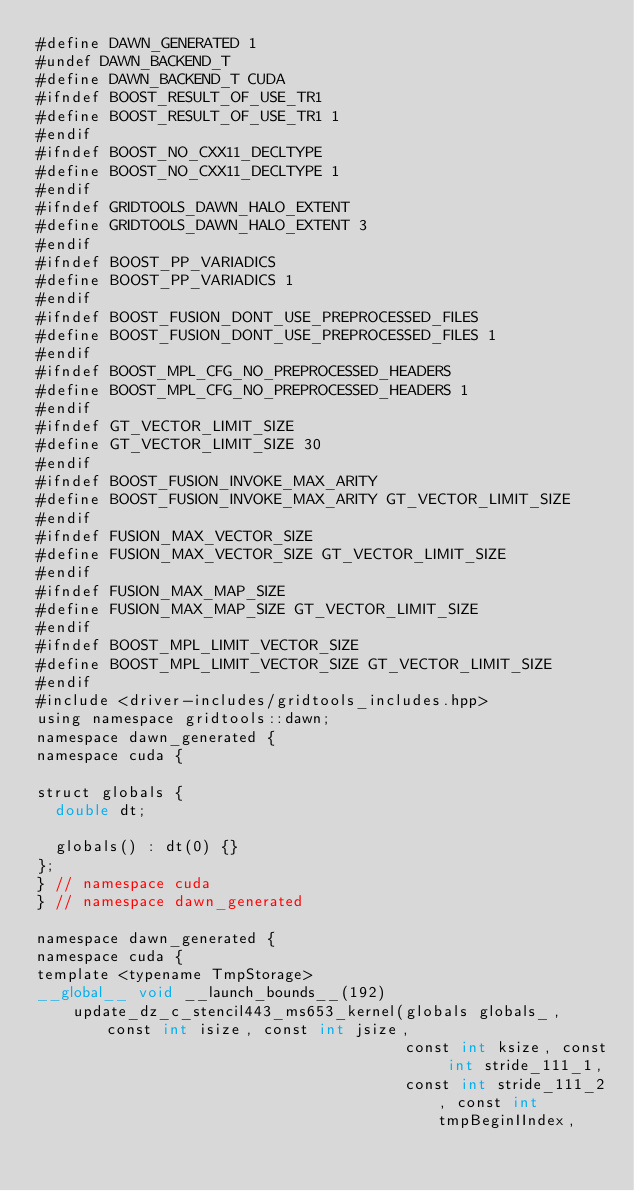Convert code to text. <code><loc_0><loc_0><loc_500><loc_500><_Cuda_>#define DAWN_GENERATED 1
#undef DAWN_BACKEND_T
#define DAWN_BACKEND_T CUDA
#ifndef BOOST_RESULT_OF_USE_TR1
#define BOOST_RESULT_OF_USE_TR1 1
#endif
#ifndef BOOST_NO_CXX11_DECLTYPE
#define BOOST_NO_CXX11_DECLTYPE 1
#endif
#ifndef GRIDTOOLS_DAWN_HALO_EXTENT
#define GRIDTOOLS_DAWN_HALO_EXTENT 3
#endif
#ifndef BOOST_PP_VARIADICS
#define BOOST_PP_VARIADICS 1
#endif
#ifndef BOOST_FUSION_DONT_USE_PREPROCESSED_FILES
#define BOOST_FUSION_DONT_USE_PREPROCESSED_FILES 1
#endif
#ifndef BOOST_MPL_CFG_NO_PREPROCESSED_HEADERS
#define BOOST_MPL_CFG_NO_PREPROCESSED_HEADERS 1
#endif
#ifndef GT_VECTOR_LIMIT_SIZE
#define GT_VECTOR_LIMIT_SIZE 30
#endif
#ifndef BOOST_FUSION_INVOKE_MAX_ARITY
#define BOOST_FUSION_INVOKE_MAX_ARITY GT_VECTOR_LIMIT_SIZE
#endif
#ifndef FUSION_MAX_VECTOR_SIZE
#define FUSION_MAX_VECTOR_SIZE GT_VECTOR_LIMIT_SIZE
#endif
#ifndef FUSION_MAX_MAP_SIZE
#define FUSION_MAX_MAP_SIZE GT_VECTOR_LIMIT_SIZE
#endif
#ifndef BOOST_MPL_LIMIT_VECTOR_SIZE
#define BOOST_MPL_LIMIT_VECTOR_SIZE GT_VECTOR_LIMIT_SIZE
#endif
#include <driver-includes/gridtools_includes.hpp>
using namespace gridtools::dawn;
namespace dawn_generated {
namespace cuda {

struct globals {
  double dt;

  globals() : dt(0) {}
};
} // namespace cuda
} // namespace dawn_generated

namespace dawn_generated {
namespace cuda {
template <typename TmpStorage>
__global__ void __launch_bounds__(192)
    update_dz_c_stencil443_ms653_kernel(globals globals_, const int isize, const int jsize,
                                        const int ksize, const int stride_111_1,
                                        const int stride_111_2, const int tmpBeginIIndex,</code> 